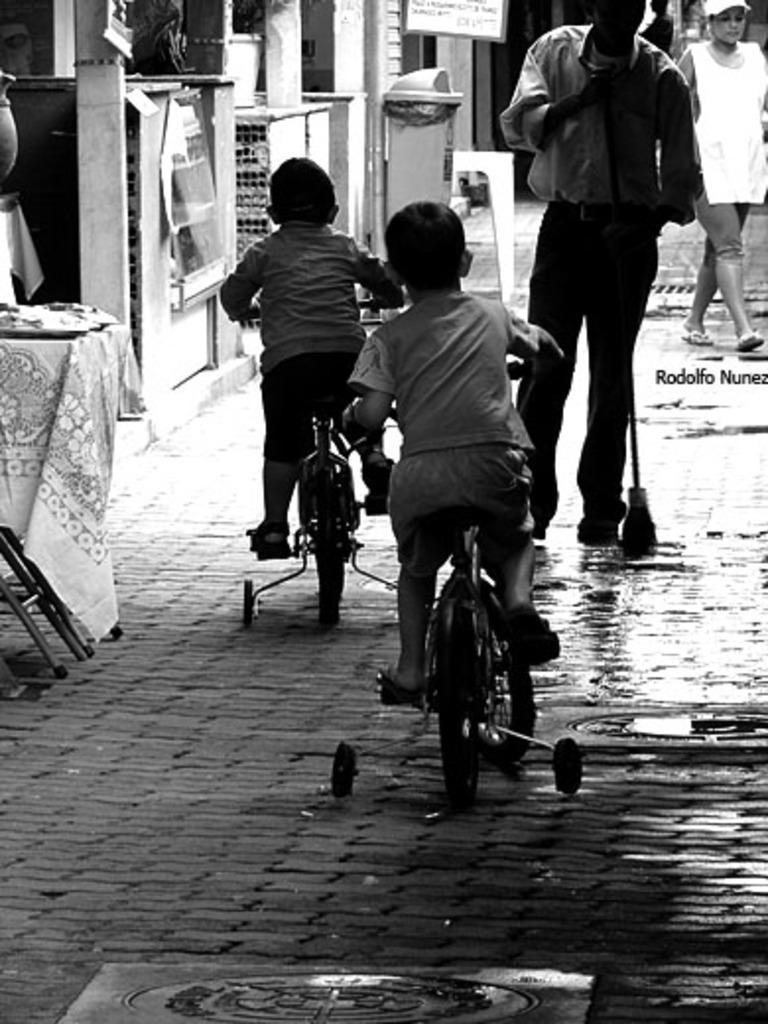How would you summarize this image in a sentence or two? In this picture we can see four people, two kids are riding bicycle and two persons are walking on the path way, in the background we can see a dustbin and a hoarding. 